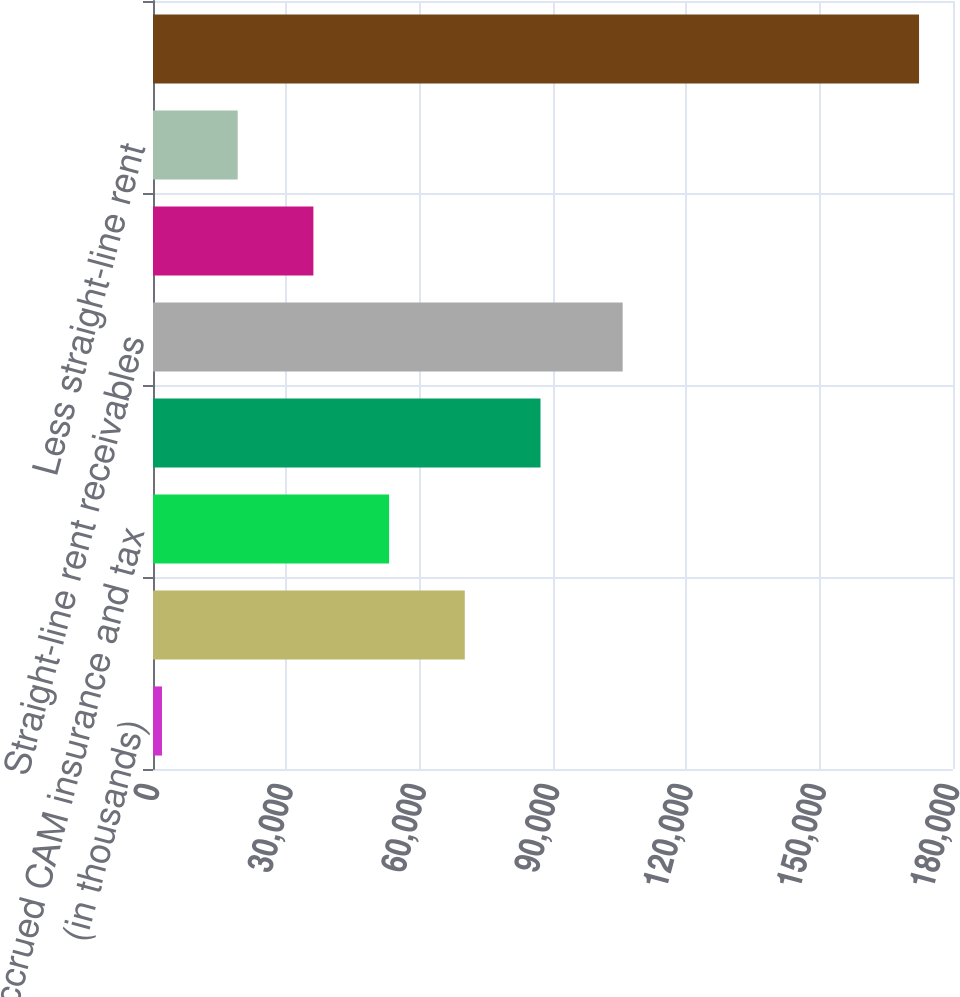Convert chart. <chart><loc_0><loc_0><loc_500><loc_500><bar_chart><fcel>(in thousands)<fcel>Billed tenant receivables<fcel>Accrued CAM insurance and tax<fcel>Other receivables<fcel>Straight-line rent receivables<fcel>Less allowance for doubtful<fcel>Less straight-line rent<fcel>Total tenant and other<nl><fcel>2018<fcel>70154.4<fcel>53120.3<fcel>87188.5<fcel>105677<fcel>36086.2<fcel>19052.1<fcel>172359<nl></chart> 